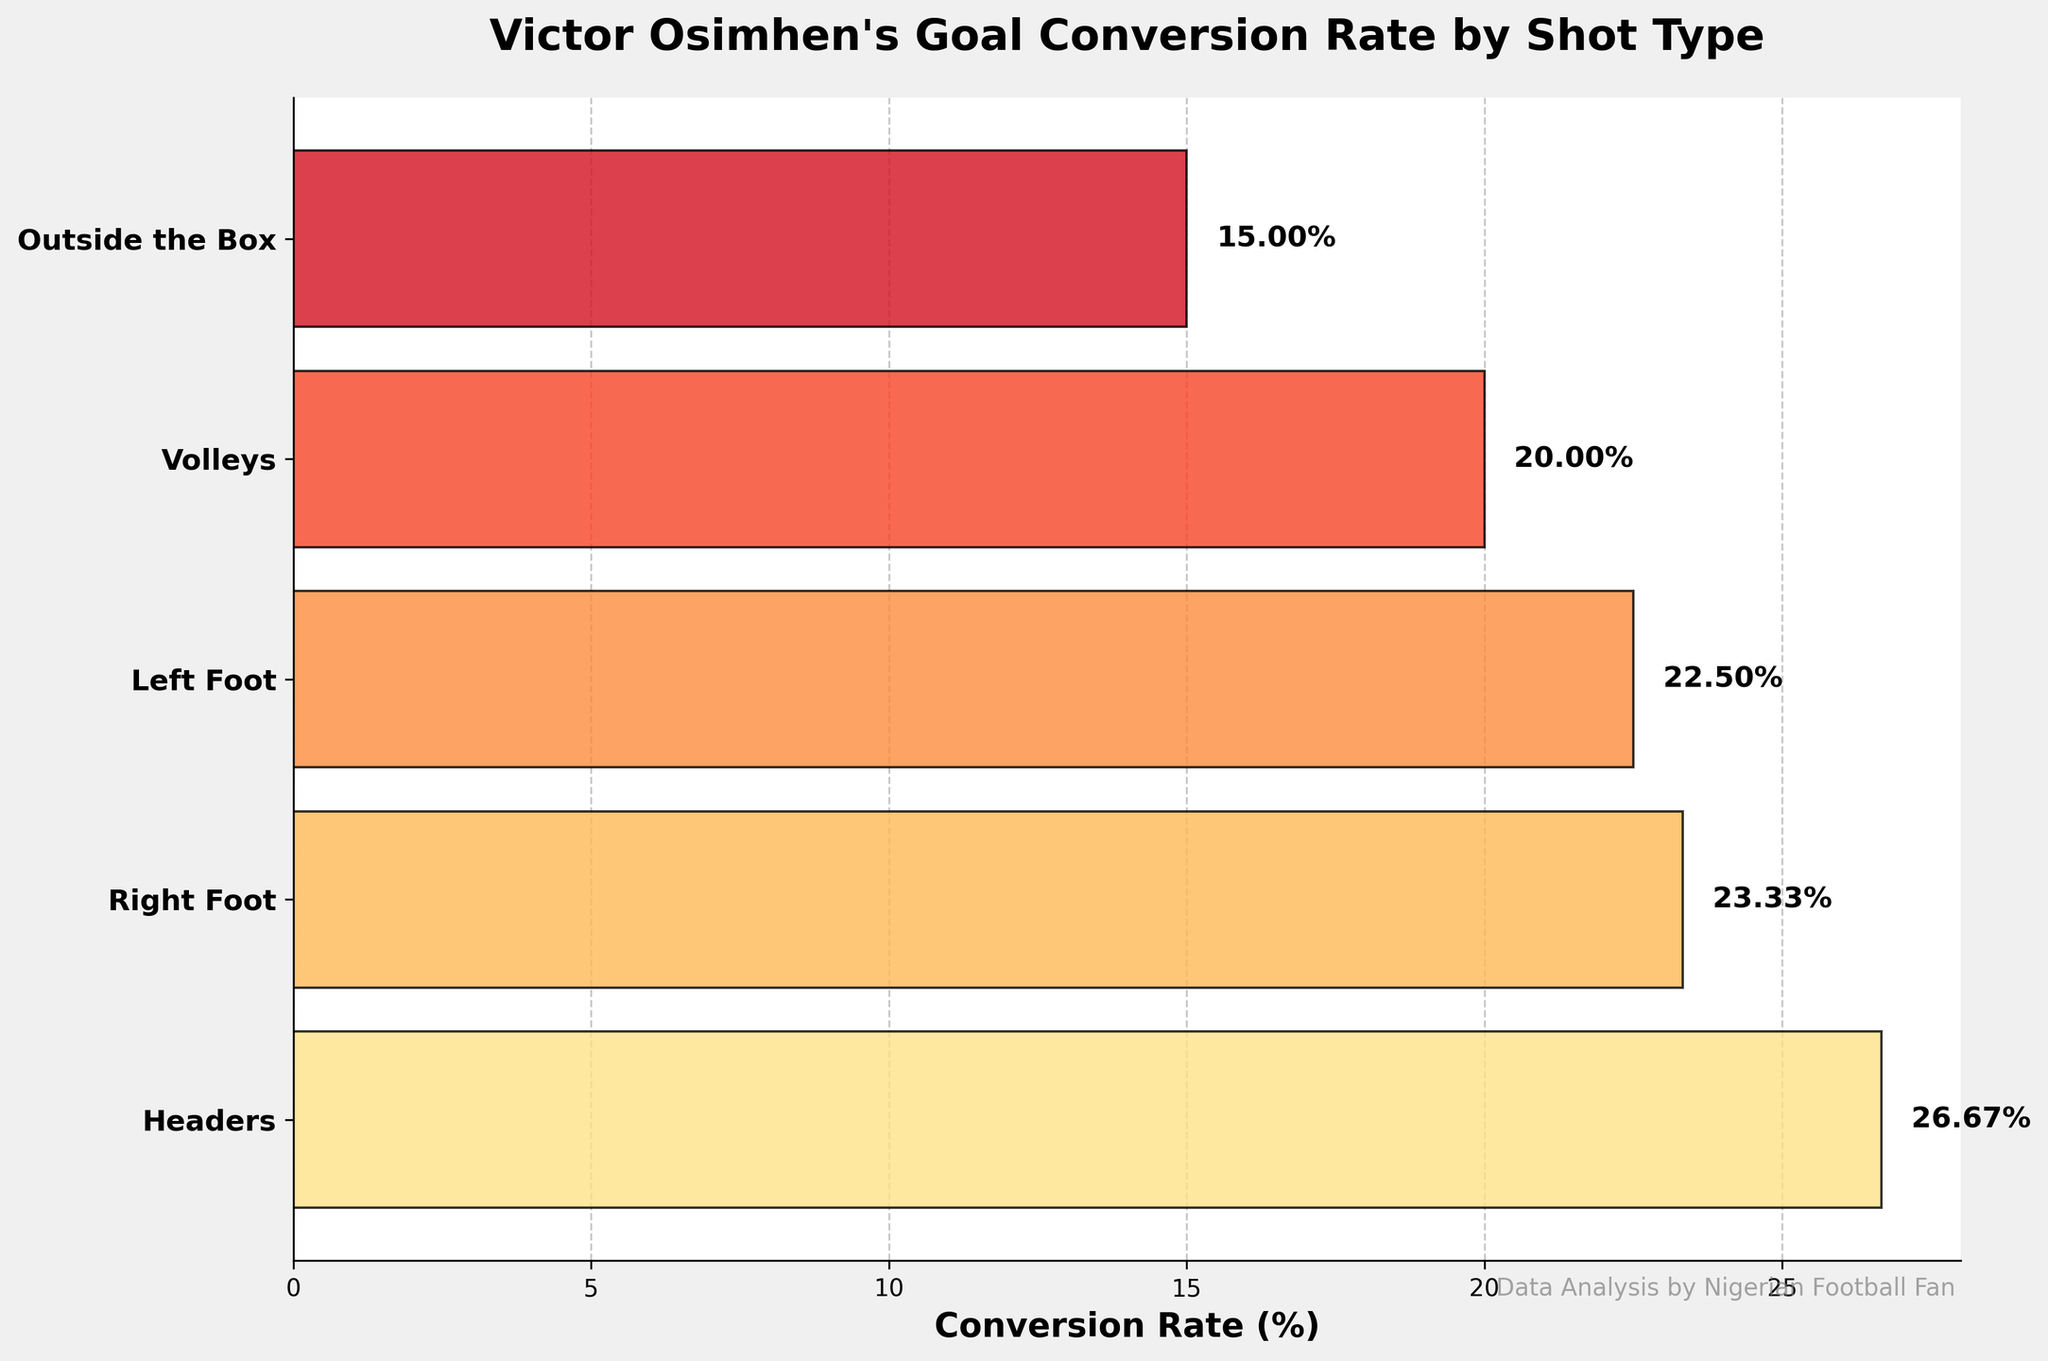What's the title of the figure? The title is located at the top of the figure in a larger, bold font. It provides a clear summary of what the figure represents.
Answer: Victor Osimhen's Goal Conversion Rate by Shot Type What is the conversion rate for shots with the right foot? The conversion rate is shown as a percentage in the horizontal bar corresponding to the "Right Foot" category, also labeled directly on the bar.
Answer: 23.33% Which shot type has the lowest goal conversion rate? By examining the lengths of the horizontal bars, we see that the "Outside the Box" category has the shortest bar, indicating the lowest conversion rate.
Answer: Outside the Box Compare the conversion rates of headers and volleys. Which is higher? The figure shows the horizontal bars and their respective percentages. The bar for headers is longer and has a higher percentage (26.67%) compared to volleys (20.00%).
Answer: Headers What is the sum of the conversion rates for headers and left foot shots? Add the conversion rates of the headers (26.67%) and left foot shots (22.50%).
Answer: 49.17% What's the difference in conversion rate between right foot and outside the box shots? Subtract the conversion rate of outside the box shots (15.00%) from the conversion rate of right foot shots (23.33%).
Answer: 8.33% Which shot type has the highest goal conversion rate? By examining the lengths of the horizontal bars, we see that the "Headers" category has the longest bar, indicating it has the highest conversion rate.
Answer: Headers How many shot types are illustrated in the funnel chart? Count the number of distinct horizontal bars or categories labeled on the y-axis.
Answer: 5 Calculate the average conversion rate across all shot types. Sum all the conversion rates (26.67 + 23.33 + 22.50 + 20.00 + 15.00) to get 107.50, then divide by the number of shot types (5).
Answer: 21.50% Which two shot types have the closest conversion rates? Examine the conversion rates and find that the "Right Foot" (23.33%) and "Left Foot" (22.50%) have the closest values.
Answer: Right Foot and Left Foot 